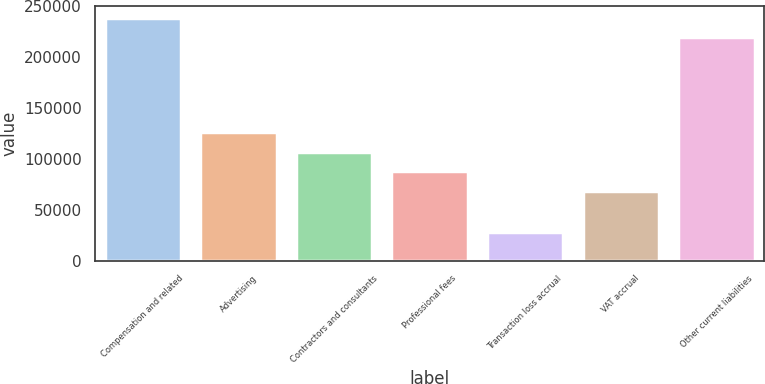<chart> <loc_0><loc_0><loc_500><loc_500><bar_chart><fcel>Compensation and related<fcel>Advertising<fcel>Contractors and consultants<fcel>Professional fees<fcel>Transaction loss accrual<fcel>VAT accrual<fcel>Other current liabilities<nl><fcel>238854<fcel>126444<fcel>107144<fcel>87842.8<fcel>28506<fcel>68542<fcel>219553<nl></chart> 